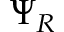Convert formula to latex. <formula><loc_0><loc_0><loc_500><loc_500>\Psi _ { R }</formula> 